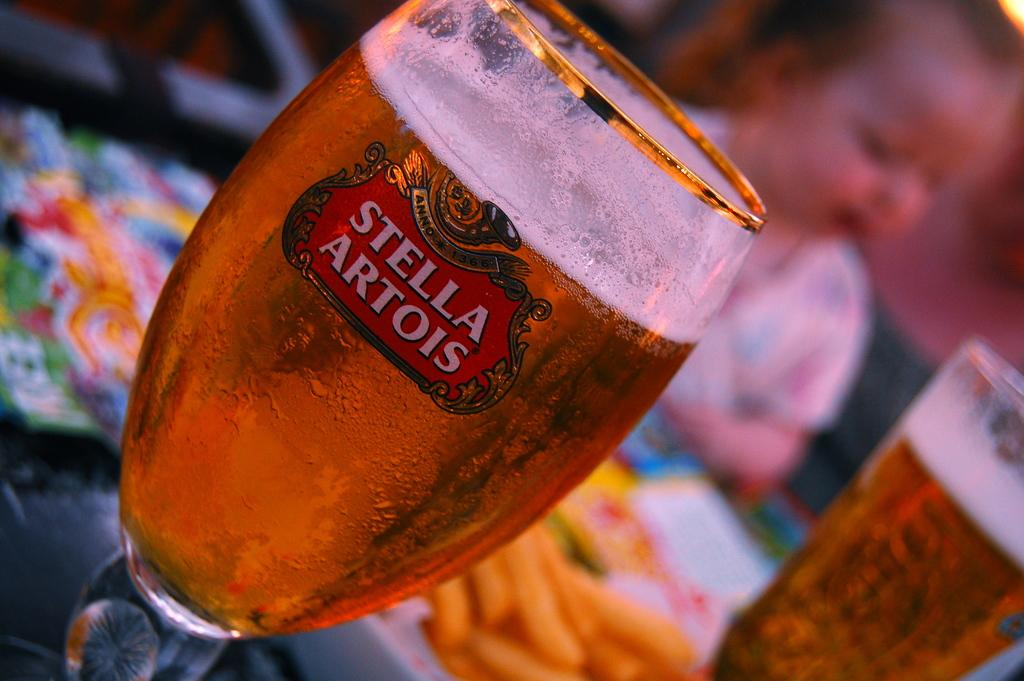<image>
Render a clear and concise summary of the photo. A glass filled with liquid and the writing "Stella Artois" on the front 